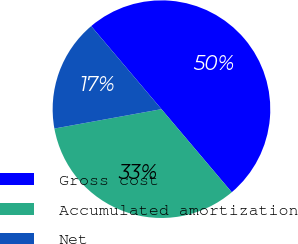Convert chart to OTSL. <chart><loc_0><loc_0><loc_500><loc_500><pie_chart><fcel>Gross cost<fcel>Accumulated amortization<fcel>Net<nl><fcel>50.0%<fcel>33.33%<fcel>16.67%<nl></chart> 